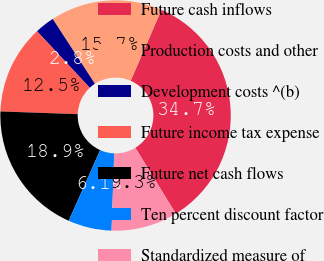Convert chart to OTSL. <chart><loc_0><loc_0><loc_500><loc_500><pie_chart><fcel>Future cash inflows<fcel>Production costs and other<fcel>Development costs ^(b)<fcel>Future income tax expense<fcel>Future net cash flows<fcel>Ten percent discount factor<fcel>Standardized measure of<nl><fcel>34.72%<fcel>15.7%<fcel>2.76%<fcel>12.5%<fcel>18.9%<fcel>6.11%<fcel>9.31%<nl></chart> 